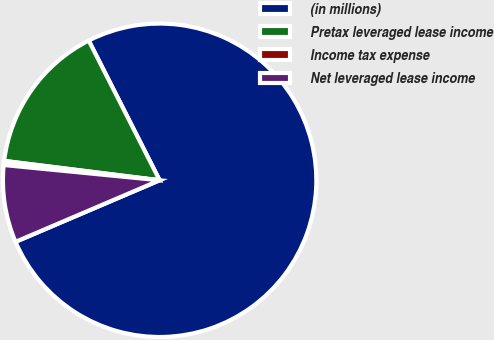<chart> <loc_0><loc_0><loc_500><loc_500><pie_chart><fcel>(in millions)<fcel>Pretax leveraged lease income<fcel>Income tax expense<fcel>Net leveraged lease income<nl><fcel>76.06%<fcel>15.55%<fcel>0.42%<fcel>7.98%<nl></chart> 